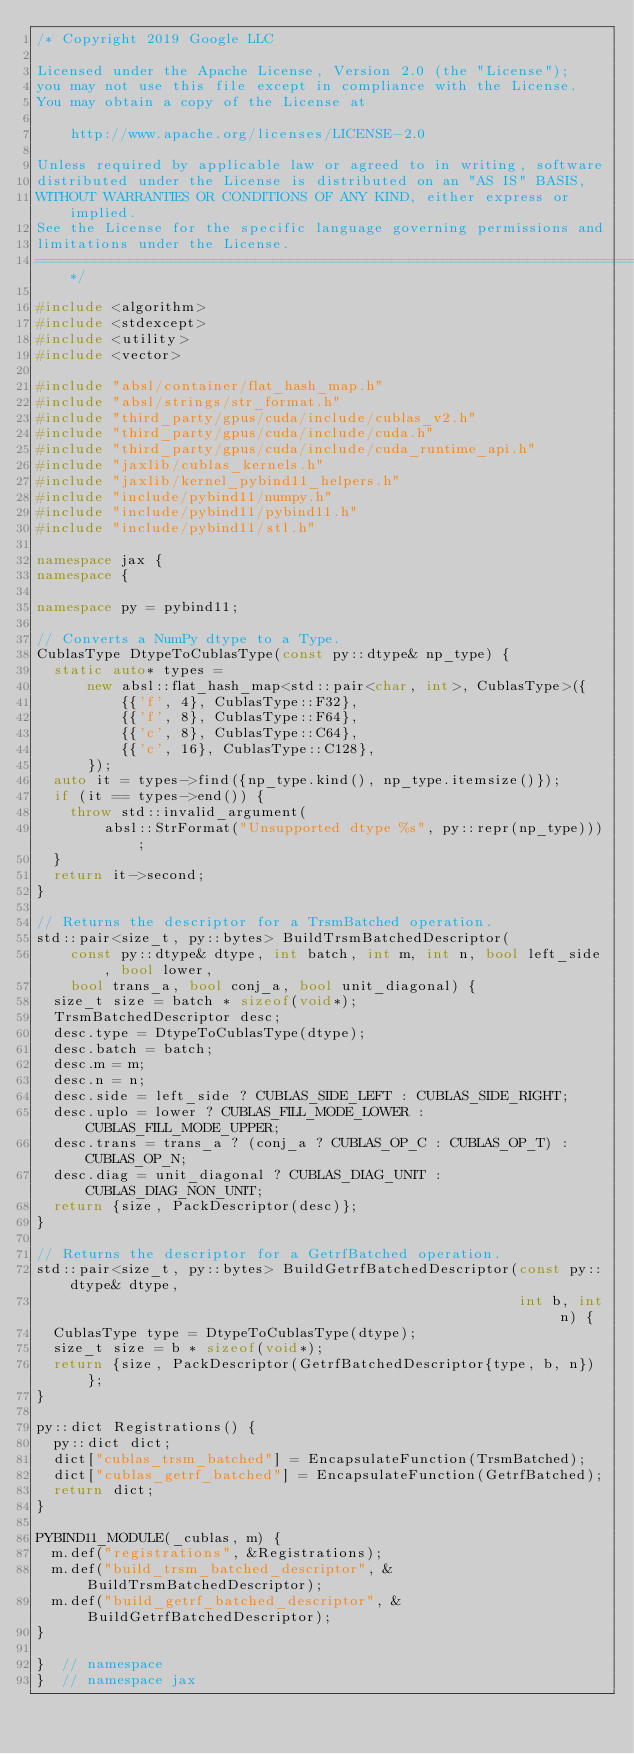<code> <loc_0><loc_0><loc_500><loc_500><_C++_>/* Copyright 2019 Google LLC

Licensed under the Apache License, Version 2.0 (the "License");
you may not use this file except in compliance with the License.
You may obtain a copy of the License at

    http://www.apache.org/licenses/LICENSE-2.0

Unless required by applicable law or agreed to in writing, software
distributed under the License is distributed on an "AS IS" BASIS,
WITHOUT WARRANTIES OR CONDITIONS OF ANY KIND, either express or implied.
See the License for the specific language governing permissions and
limitations under the License.
==============================================================================*/

#include <algorithm>
#include <stdexcept>
#include <utility>
#include <vector>

#include "absl/container/flat_hash_map.h"
#include "absl/strings/str_format.h"
#include "third_party/gpus/cuda/include/cublas_v2.h"
#include "third_party/gpus/cuda/include/cuda.h"
#include "third_party/gpus/cuda/include/cuda_runtime_api.h"
#include "jaxlib/cublas_kernels.h"
#include "jaxlib/kernel_pybind11_helpers.h"
#include "include/pybind11/numpy.h"
#include "include/pybind11/pybind11.h"
#include "include/pybind11/stl.h"

namespace jax {
namespace {

namespace py = pybind11;

// Converts a NumPy dtype to a Type.
CublasType DtypeToCublasType(const py::dtype& np_type) {
  static auto* types =
      new absl::flat_hash_map<std::pair<char, int>, CublasType>({
          {{'f', 4}, CublasType::F32},
          {{'f', 8}, CublasType::F64},
          {{'c', 8}, CublasType::C64},
          {{'c', 16}, CublasType::C128},
      });
  auto it = types->find({np_type.kind(), np_type.itemsize()});
  if (it == types->end()) {
    throw std::invalid_argument(
        absl::StrFormat("Unsupported dtype %s", py::repr(np_type)));
  }
  return it->second;
}

// Returns the descriptor for a TrsmBatched operation.
std::pair<size_t, py::bytes> BuildTrsmBatchedDescriptor(
    const py::dtype& dtype, int batch, int m, int n, bool left_side, bool lower,
    bool trans_a, bool conj_a, bool unit_diagonal) {
  size_t size = batch * sizeof(void*);
  TrsmBatchedDescriptor desc;
  desc.type = DtypeToCublasType(dtype);
  desc.batch = batch;
  desc.m = m;
  desc.n = n;
  desc.side = left_side ? CUBLAS_SIDE_LEFT : CUBLAS_SIDE_RIGHT;
  desc.uplo = lower ? CUBLAS_FILL_MODE_LOWER : CUBLAS_FILL_MODE_UPPER;
  desc.trans = trans_a ? (conj_a ? CUBLAS_OP_C : CUBLAS_OP_T) : CUBLAS_OP_N;
  desc.diag = unit_diagonal ? CUBLAS_DIAG_UNIT : CUBLAS_DIAG_NON_UNIT;
  return {size, PackDescriptor(desc)};
}

// Returns the descriptor for a GetrfBatched operation.
std::pair<size_t, py::bytes> BuildGetrfBatchedDescriptor(const py::dtype& dtype,
                                                         int b, int n) {
  CublasType type = DtypeToCublasType(dtype);
  size_t size = b * sizeof(void*);
  return {size, PackDescriptor(GetrfBatchedDescriptor{type, b, n})};
}

py::dict Registrations() {
  py::dict dict;
  dict["cublas_trsm_batched"] = EncapsulateFunction(TrsmBatched);
  dict["cublas_getrf_batched"] = EncapsulateFunction(GetrfBatched);
  return dict;
}

PYBIND11_MODULE(_cublas, m) {
  m.def("registrations", &Registrations);
  m.def("build_trsm_batched_descriptor", &BuildTrsmBatchedDescriptor);
  m.def("build_getrf_batched_descriptor", &BuildGetrfBatchedDescriptor);
}

}  // namespace
}  // namespace jax
</code> 